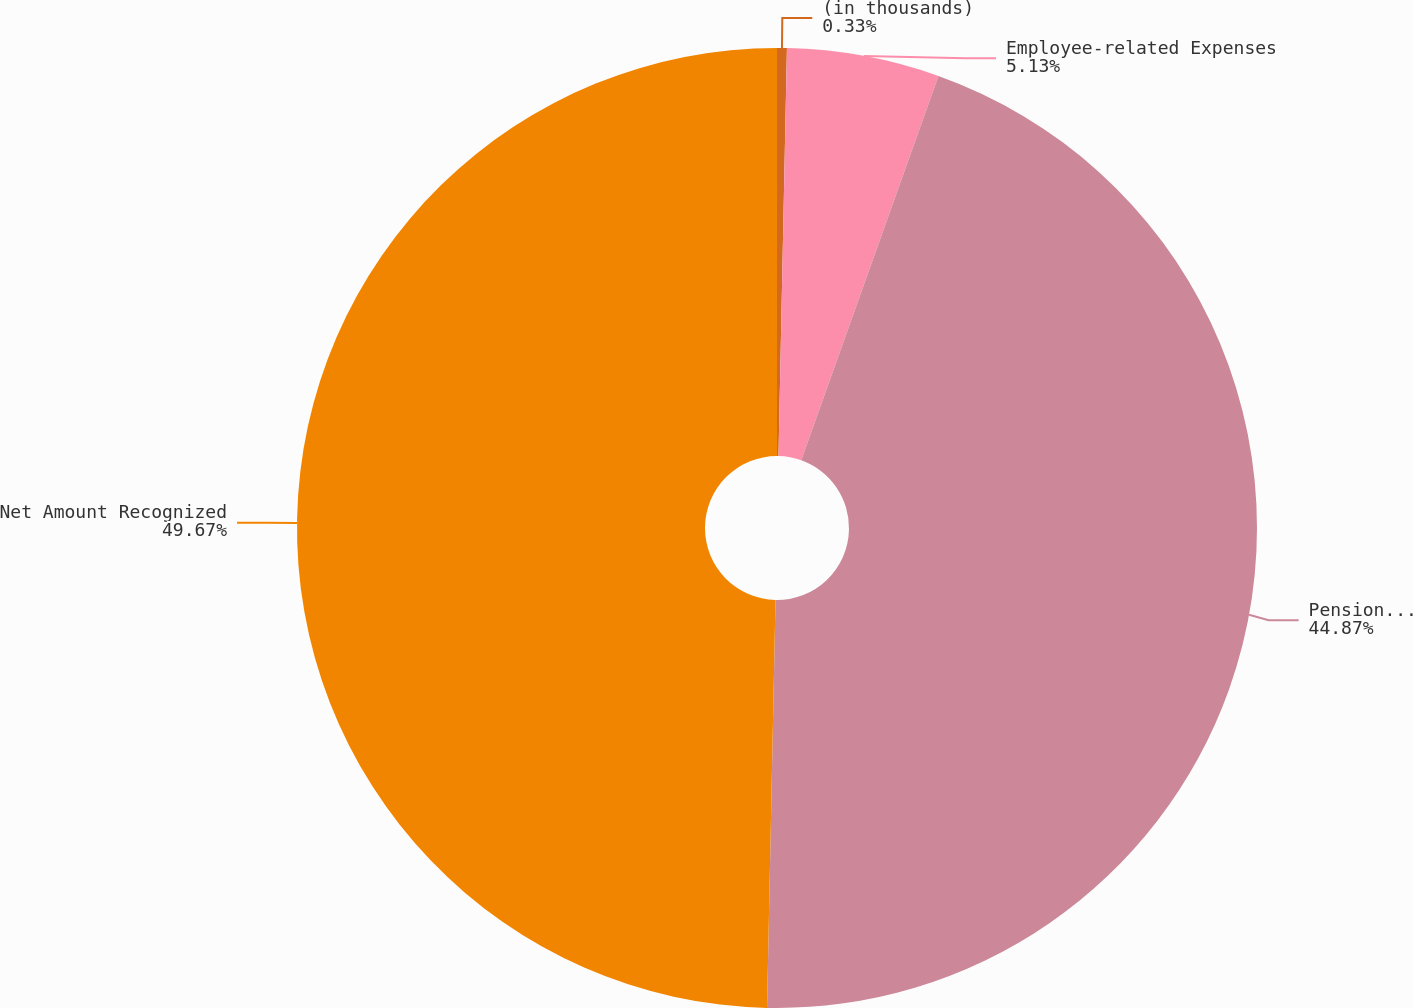<chart> <loc_0><loc_0><loc_500><loc_500><pie_chart><fcel>(in thousands)<fcel>Employee-related Expenses<fcel>Pension and Post-retirement<fcel>Net Amount Recognized<nl><fcel>0.33%<fcel>5.13%<fcel>44.87%<fcel>49.67%<nl></chart> 